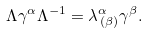<formula> <loc_0><loc_0><loc_500><loc_500>\Lambda \gamma ^ { \alpha } \Lambda ^ { - 1 } = \lambda ^ { \alpha } _ { \, ( \beta ) } \gamma ^ { \beta } .</formula> 